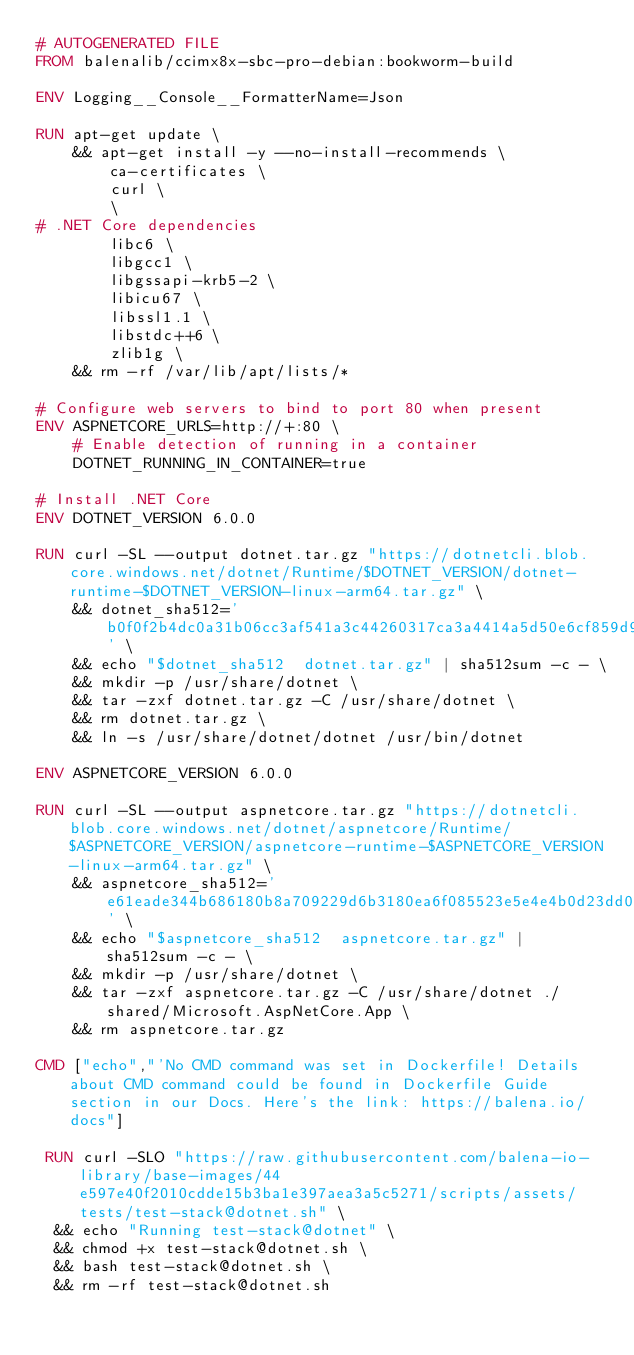<code> <loc_0><loc_0><loc_500><loc_500><_Dockerfile_># AUTOGENERATED FILE
FROM balenalib/ccimx8x-sbc-pro-debian:bookworm-build

ENV Logging__Console__FormatterName=Json

RUN apt-get update \
    && apt-get install -y --no-install-recommends \
        ca-certificates \
        curl \
        \
# .NET Core dependencies
        libc6 \
        libgcc1 \
        libgssapi-krb5-2 \
        libicu67 \
        libssl1.1 \
        libstdc++6 \
        zlib1g \
    && rm -rf /var/lib/apt/lists/*

# Configure web servers to bind to port 80 when present
ENV ASPNETCORE_URLS=http://+:80 \
    # Enable detection of running in a container
    DOTNET_RUNNING_IN_CONTAINER=true

# Install .NET Core
ENV DOTNET_VERSION 6.0.0

RUN curl -SL --output dotnet.tar.gz "https://dotnetcli.blob.core.windows.net/dotnet/Runtime/$DOTNET_VERSION/dotnet-runtime-$DOTNET_VERSION-linux-arm64.tar.gz" \
    && dotnet_sha512='b0f0f2b4dc0a31b06cc3af541a3c44260317ca3a4414a5d50e6cf859d93821b3d2c2246baec9f96004aeb1eb0e353631283b11cf3acc134d4694f0ed71c9503d' \
    && echo "$dotnet_sha512  dotnet.tar.gz" | sha512sum -c - \
    && mkdir -p /usr/share/dotnet \
    && tar -zxf dotnet.tar.gz -C /usr/share/dotnet \
    && rm dotnet.tar.gz \
    && ln -s /usr/share/dotnet/dotnet /usr/bin/dotnet

ENV ASPNETCORE_VERSION 6.0.0

RUN curl -SL --output aspnetcore.tar.gz "https://dotnetcli.blob.core.windows.net/dotnet/aspnetcore/Runtime/$ASPNETCORE_VERSION/aspnetcore-runtime-$ASPNETCORE_VERSION-linux-arm64.tar.gz" \
    && aspnetcore_sha512='e61eade344b686180b8a709229d6b3180ea6f085523e5e4e4b0d23dd00cf9edce3e51a920c986b1bab7d04d8cab5aae219c3b533b6feb84b32a02810936859b0' \
    && echo "$aspnetcore_sha512  aspnetcore.tar.gz" | sha512sum -c - \
    && mkdir -p /usr/share/dotnet \
    && tar -zxf aspnetcore.tar.gz -C /usr/share/dotnet ./shared/Microsoft.AspNetCore.App \
    && rm aspnetcore.tar.gz

CMD ["echo","'No CMD command was set in Dockerfile! Details about CMD command could be found in Dockerfile Guide section in our Docs. Here's the link: https://balena.io/docs"]

 RUN curl -SLO "https://raw.githubusercontent.com/balena-io-library/base-images/44e597e40f2010cdde15b3ba1e397aea3a5c5271/scripts/assets/tests/test-stack@dotnet.sh" \
  && echo "Running test-stack@dotnet" \
  && chmod +x test-stack@dotnet.sh \
  && bash test-stack@dotnet.sh \
  && rm -rf test-stack@dotnet.sh 
</code> 